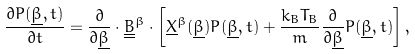<formula> <loc_0><loc_0><loc_500><loc_500>\frac { \partial P ( \underline { \beta } , t ) } { \partial t } = \frac { \partial } { \partial \underline { \beta } } \cdot \underline { \underline { B } } ^ { \beta } \cdot \left [ \underline { X } ^ { \beta } ( \underline { \beta } ) P ( \underline { \beta } , t ) + \frac { k _ { B } T _ { B } } { m } \frac { \partial } { \partial \underline { \beta } } P ( \underline { \beta } , t ) \right ] ,</formula> 